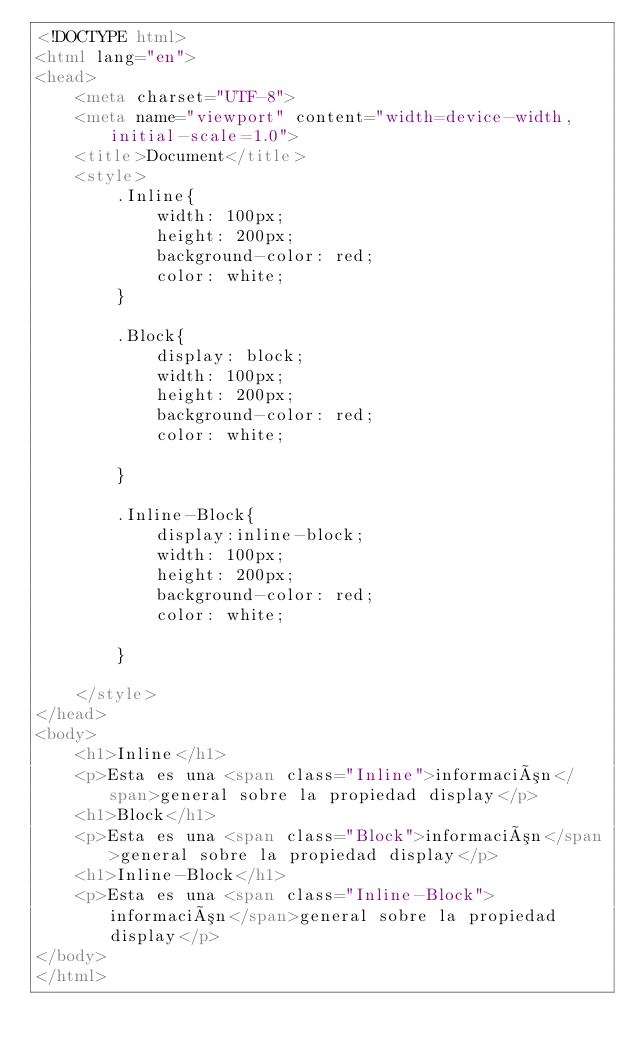<code> <loc_0><loc_0><loc_500><loc_500><_HTML_><!DOCTYPE html>
<html lang="en">
<head>
    <meta charset="UTF-8">
    <meta name="viewport" content="width=device-width, initial-scale=1.0">
    <title>Document</title>
    <style>
        .Inline{
            width: 100px;
            height: 200px;
            background-color: red;
            color: white;
        }

        .Block{
            display: block;
            width: 100px;
            height: 200px;
            background-color: red;
            color: white;

        }

        .Inline-Block{
            display:inline-block;
            width: 100px;
            height: 200px;
            background-color: red;
            color: white;

        }
        
    </style>
</head>
<body>
    <h1>Inline</h1>
    <p>Esta es una <span class="Inline">información</span>general sobre la propiedad display</p>
    <h1>Block</h1>
    <p>Esta es una <span class="Block">información</span>general sobre la propiedad display</p>
    <h1>Inline-Block</h1>
    <p>Esta es una <span class="Inline-Block">información</span>general sobre la propiedad display</p>
</body>
</html></code> 